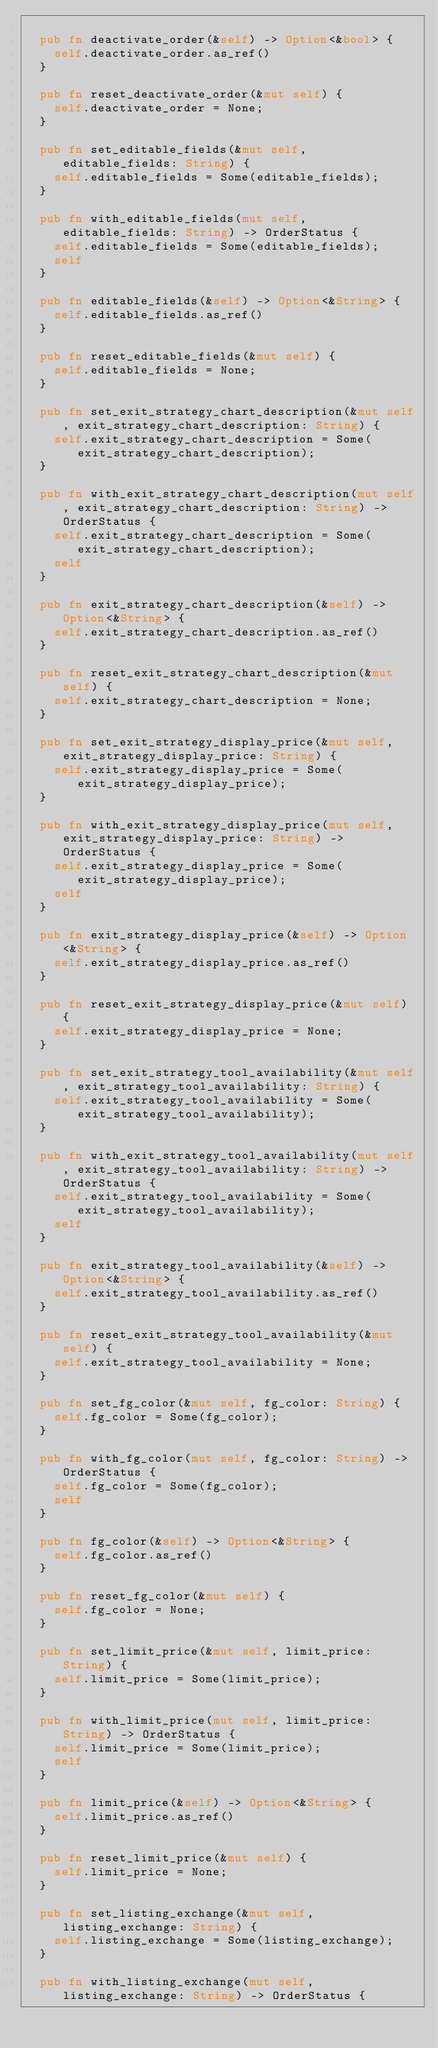<code> <loc_0><loc_0><loc_500><loc_500><_Rust_>
  pub fn deactivate_order(&self) -> Option<&bool> {
    self.deactivate_order.as_ref()
  }

  pub fn reset_deactivate_order(&mut self) {
    self.deactivate_order = None;
  }

  pub fn set_editable_fields(&mut self, editable_fields: String) {
    self.editable_fields = Some(editable_fields);
  }

  pub fn with_editable_fields(mut self, editable_fields: String) -> OrderStatus {
    self.editable_fields = Some(editable_fields);
    self
  }

  pub fn editable_fields(&self) -> Option<&String> {
    self.editable_fields.as_ref()
  }

  pub fn reset_editable_fields(&mut self) {
    self.editable_fields = None;
  }

  pub fn set_exit_strategy_chart_description(&mut self, exit_strategy_chart_description: String) {
    self.exit_strategy_chart_description = Some(exit_strategy_chart_description);
  }

  pub fn with_exit_strategy_chart_description(mut self, exit_strategy_chart_description: String) -> OrderStatus {
    self.exit_strategy_chart_description = Some(exit_strategy_chart_description);
    self
  }

  pub fn exit_strategy_chart_description(&self) -> Option<&String> {
    self.exit_strategy_chart_description.as_ref()
  }

  pub fn reset_exit_strategy_chart_description(&mut self) {
    self.exit_strategy_chart_description = None;
  }

  pub fn set_exit_strategy_display_price(&mut self, exit_strategy_display_price: String) {
    self.exit_strategy_display_price = Some(exit_strategy_display_price);
  }

  pub fn with_exit_strategy_display_price(mut self, exit_strategy_display_price: String) -> OrderStatus {
    self.exit_strategy_display_price = Some(exit_strategy_display_price);
    self
  }

  pub fn exit_strategy_display_price(&self) -> Option<&String> {
    self.exit_strategy_display_price.as_ref()
  }

  pub fn reset_exit_strategy_display_price(&mut self) {
    self.exit_strategy_display_price = None;
  }

  pub fn set_exit_strategy_tool_availability(&mut self, exit_strategy_tool_availability: String) {
    self.exit_strategy_tool_availability = Some(exit_strategy_tool_availability);
  }

  pub fn with_exit_strategy_tool_availability(mut self, exit_strategy_tool_availability: String) -> OrderStatus {
    self.exit_strategy_tool_availability = Some(exit_strategy_tool_availability);
    self
  }

  pub fn exit_strategy_tool_availability(&self) -> Option<&String> {
    self.exit_strategy_tool_availability.as_ref()
  }

  pub fn reset_exit_strategy_tool_availability(&mut self) {
    self.exit_strategy_tool_availability = None;
  }

  pub fn set_fg_color(&mut self, fg_color: String) {
    self.fg_color = Some(fg_color);
  }

  pub fn with_fg_color(mut self, fg_color: String) -> OrderStatus {
    self.fg_color = Some(fg_color);
    self
  }

  pub fn fg_color(&self) -> Option<&String> {
    self.fg_color.as_ref()
  }

  pub fn reset_fg_color(&mut self) {
    self.fg_color = None;
  }

  pub fn set_limit_price(&mut self, limit_price: String) {
    self.limit_price = Some(limit_price);
  }

  pub fn with_limit_price(mut self, limit_price: String) -> OrderStatus {
    self.limit_price = Some(limit_price);
    self
  }

  pub fn limit_price(&self) -> Option<&String> {
    self.limit_price.as_ref()
  }

  pub fn reset_limit_price(&mut self) {
    self.limit_price = None;
  }

  pub fn set_listing_exchange(&mut self, listing_exchange: String) {
    self.listing_exchange = Some(listing_exchange);
  }

  pub fn with_listing_exchange(mut self, listing_exchange: String) -> OrderStatus {</code> 